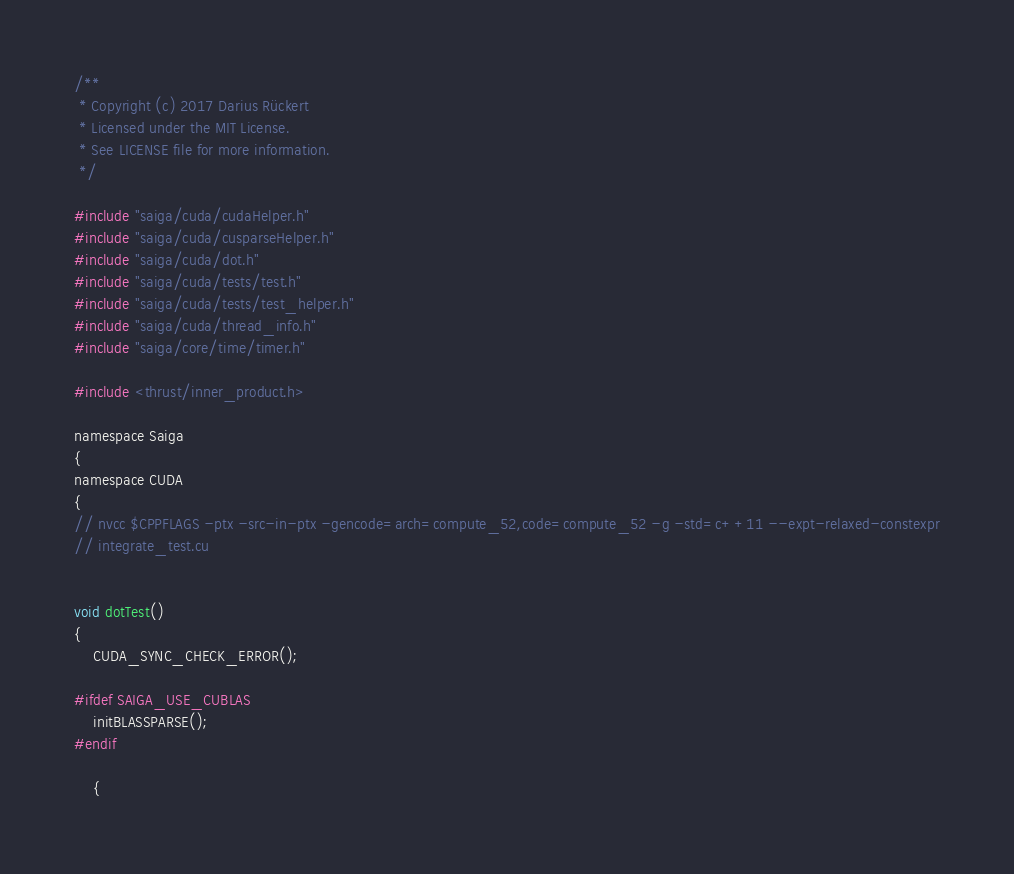Convert code to text. <code><loc_0><loc_0><loc_500><loc_500><_Cuda_>/**
 * Copyright (c) 2017 Darius Rückert
 * Licensed under the MIT License.
 * See LICENSE file for more information.
 */

#include "saiga/cuda/cudaHelper.h"
#include "saiga/cuda/cusparseHelper.h"
#include "saiga/cuda/dot.h"
#include "saiga/cuda/tests/test.h"
#include "saiga/cuda/tests/test_helper.h"
#include "saiga/cuda/thread_info.h"
#include "saiga/core/time/timer.h"

#include <thrust/inner_product.h>

namespace Saiga
{
namespace CUDA
{
// nvcc $CPPFLAGS -ptx -src-in-ptx -gencode=arch=compute_52,code=compute_52 -g -std=c++11 --expt-relaxed-constexpr
// integrate_test.cu


void dotTest()
{
    CUDA_SYNC_CHECK_ERROR();

#ifdef SAIGA_USE_CUBLAS
    initBLASSPARSE();
#endif

    {</code> 